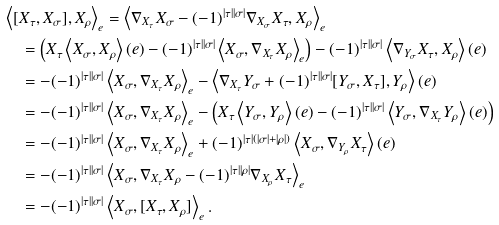Convert formula to latex. <formula><loc_0><loc_0><loc_500><loc_500>& \left < [ X _ { \tau } , X _ { \sigma } ] , X _ { \rho } \right > _ { e } = \left < \nabla _ { X _ { \tau } } X _ { \sigma } - ( - 1 ) ^ { | \tau | | \sigma | } \nabla _ { X _ { \sigma } } X _ { \tau } , X _ { \rho } \right > _ { e } \\ & \quad = \left ( X _ { \tau } \left < X _ { \sigma } , X _ { \rho } \right > ( e ) - ( - 1 ) ^ { | \tau | | \sigma | } \left < X _ { \sigma } , \nabla _ { X _ { \tau } } X _ { \rho } \right > _ { e } \right ) - ( - 1 ) ^ { | \tau | | \sigma | } \left < \nabla _ { Y _ { \sigma } } X _ { \tau } , X _ { \rho } \right > ( e ) \\ & \quad = - ( - 1 ) ^ { | \tau | | \sigma | } \left < X _ { \sigma } , \nabla _ { X _ { \tau } } X _ { \rho } \right > _ { e } - \left < \nabla _ { X _ { \tau } } Y _ { \sigma } + ( - 1 ) ^ { | \tau | | \sigma | } [ Y _ { \sigma } , X _ { \tau } ] , Y _ { \rho } \right > ( e ) \\ & \quad = - ( - 1 ) ^ { | \tau | | \sigma | } \left < X _ { \sigma } , \nabla _ { X _ { \tau } } X _ { \rho } \right > _ { e } - \left ( X _ { \tau } \left < Y _ { \sigma } , Y _ { \rho } \right > ( e ) - ( - 1 ) ^ { | \tau | | \sigma | } \left < Y _ { \sigma } , \nabla _ { X _ { \tau } } Y _ { \rho } \right > ( e ) \right ) \\ & \quad = - ( - 1 ) ^ { | \tau | | \sigma | } \left < X _ { \sigma } , \nabla _ { X _ { \tau } } X _ { \rho } \right > _ { e } + ( - 1 ) ^ { | \tau | ( | \sigma | + | \rho | ) } \left < X _ { \sigma } , \nabla _ { Y _ { \rho } } X _ { \tau } \right > ( e ) \\ & \quad = - ( - 1 ) ^ { | \tau | | \sigma | } \left < X _ { \sigma } , \nabla _ { X _ { \tau } } X _ { \rho } - ( - 1 ) ^ { | \tau | | \rho | } \nabla _ { X _ { \rho } } X _ { \tau } \right > _ { e } \\ & \quad = - ( - 1 ) ^ { | \tau | | \sigma | } \left < X _ { \sigma } , [ X _ { \tau } , X _ { \rho } ] \right > _ { e } .</formula> 